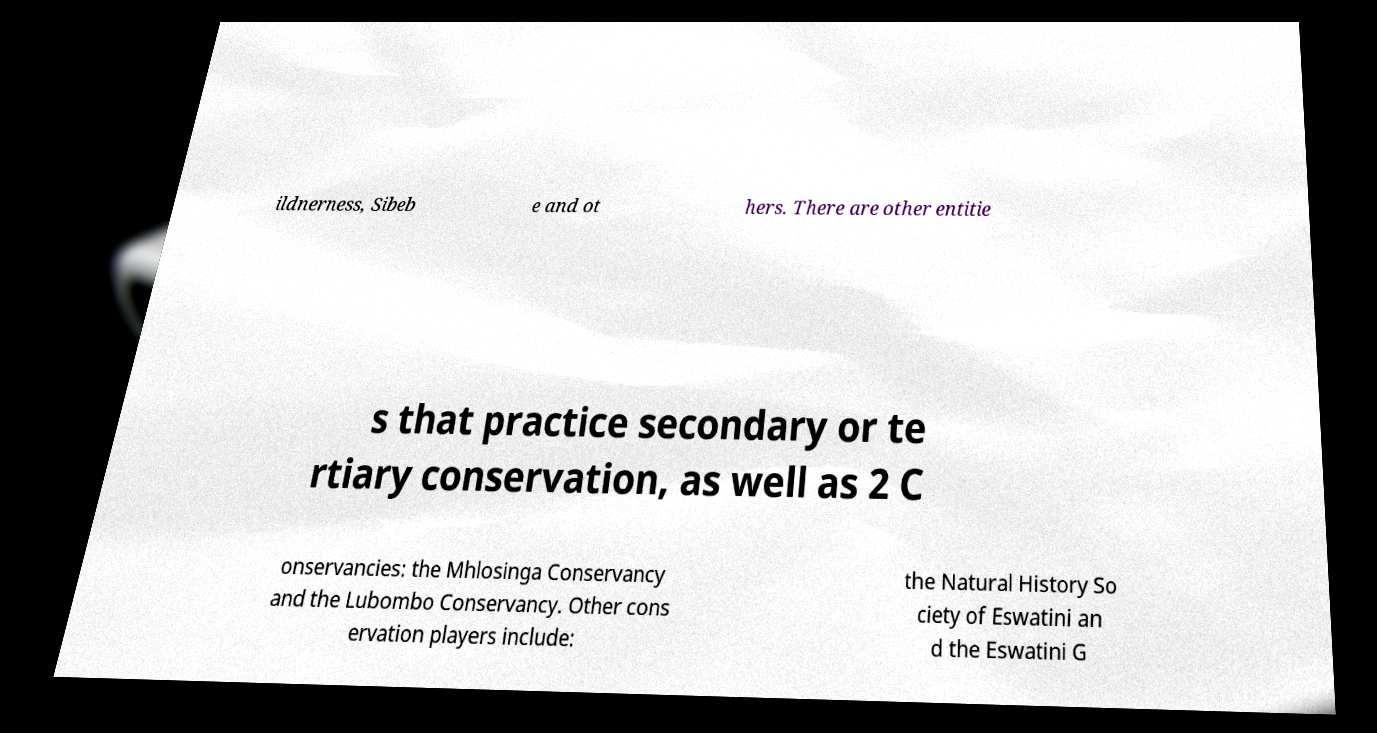Can you read and provide the text displayed in the image?This photo seems to have some interesting text. Can you extract and type it out for me? ildnerness, Sibeb e and ot hers. There are other entitie s that practice secondary or te rtiary conservation, as well as 2 C onservancies: the Mhlosinga Conservancy and the Lubombo Conservancy. Other cons ervation players include: the Natural History So ciety of Eswatini an d the Eswatini G 